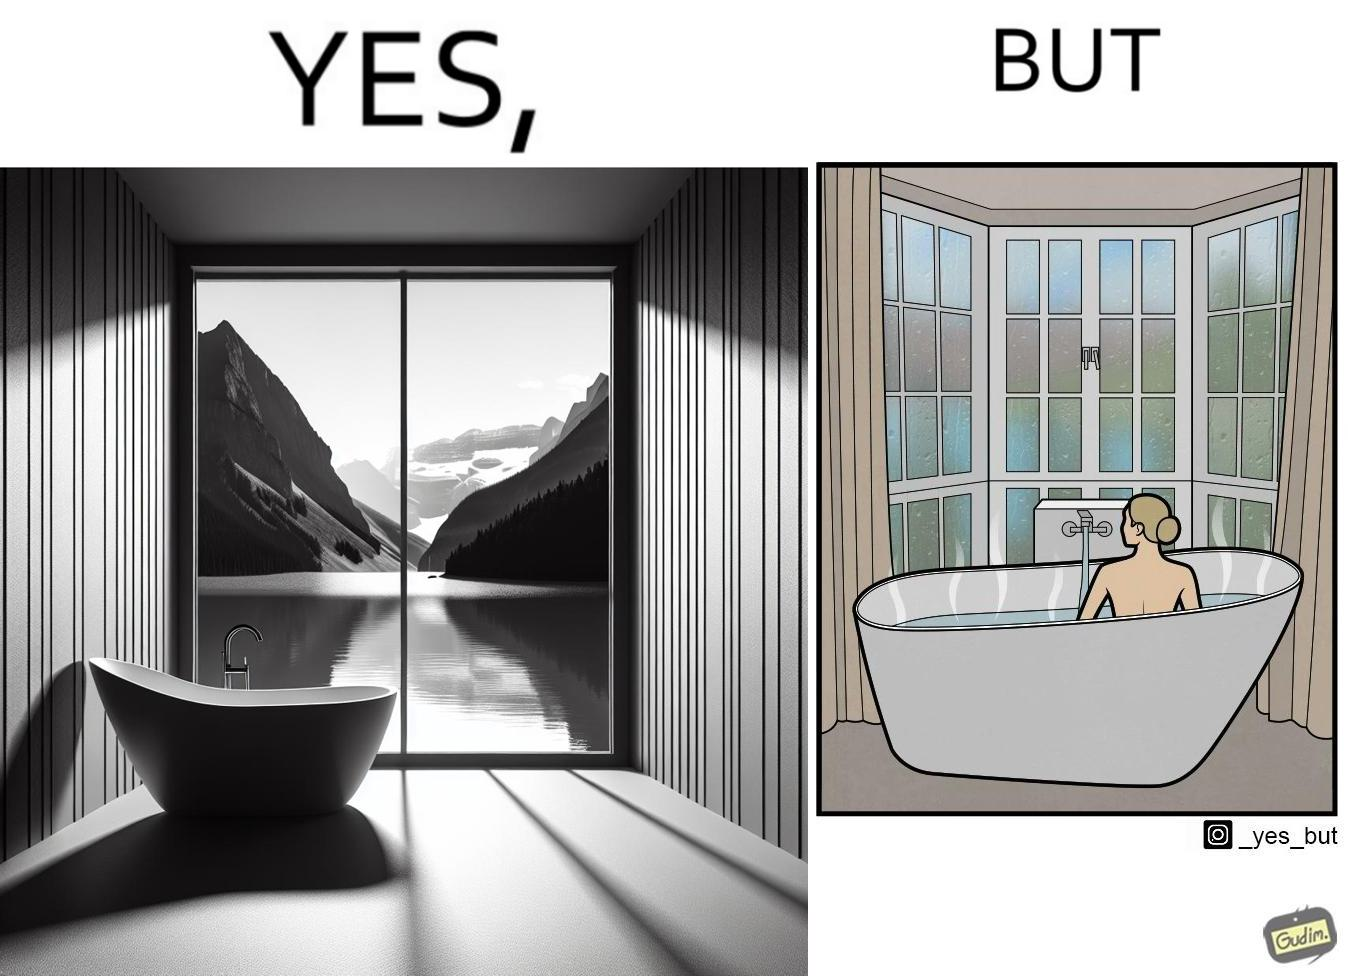Does this image contain satire or humor? Yes, this image is satirical. 